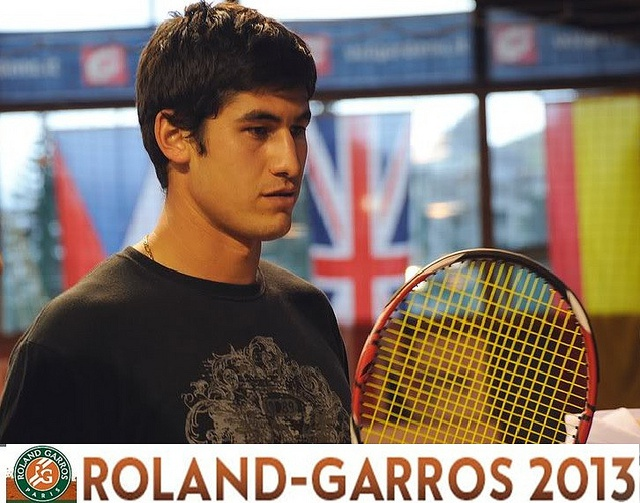Describe the objects in this image and their specific colors. I can see people in white, black, red, maroon, and orange tones and tennis racket in white, black, maroon, and olive tones in this image. 